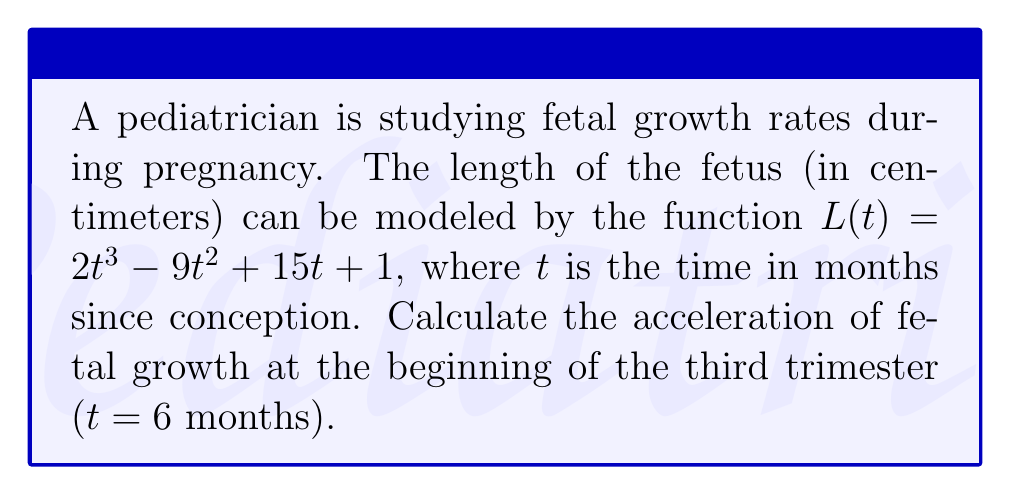Give your solution to this math problem. To find the acceleration of fetal growth, we need to calculate the second derivative of the length function $L(t)$.

Step 1: Find the first derivative (velocity of growth)
$$\frac{dL}{dt} = L'(t) = 6t^2 - 18t + 15$$

Step 2: Find the second derivative (acceleration of growth)
$$\frac{d^2L}{dt^2} = L''(t) = 12t - 18$$

Step 3: Evaluate the second derivative at t = 6 months (beginning of third trimester)
$$L''(6) = 12(6) - 18 = 72 - 18 = 54$$

The acceleration of fetal growth at the beginning of the third trimester is 54 cm/month².

This positive acceleration indicates that the rate of fetal growth is increasing at this point in pregnancy, which is consistent with the rapid growth typically observed during the third trimester.
Answer: $54$ cm/month² 